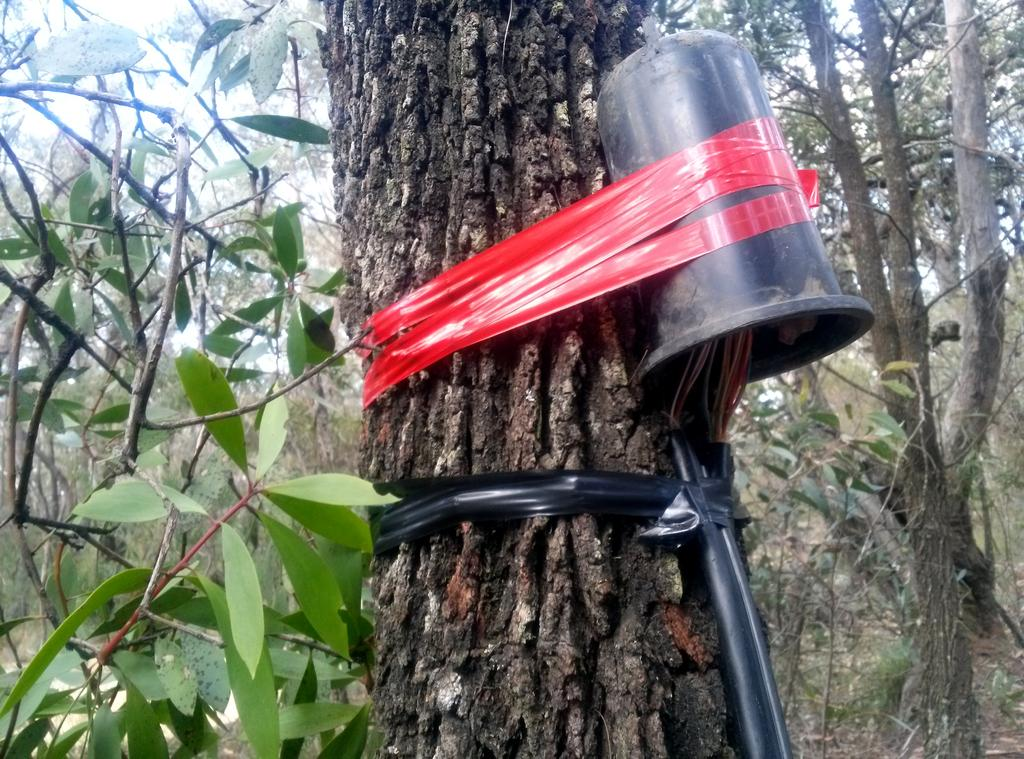What is the main object in the image? There is a tree trunk in the image. What is attached to the tree trunk? A black pipe and a black tube are attached to the tree trunk. How are the pipe and tube secured to the tree trunk? Red and black tapes are used to attach the pipe and tube to the tree trunk. What can be seen in the background of the image? There are trees visible in the background of the image. Can you tell me how many women are sitting under the tree in the image? There are no women sitting under the tree in the image; it only features a tree trunk with a black pipe and black tube attached to it. 